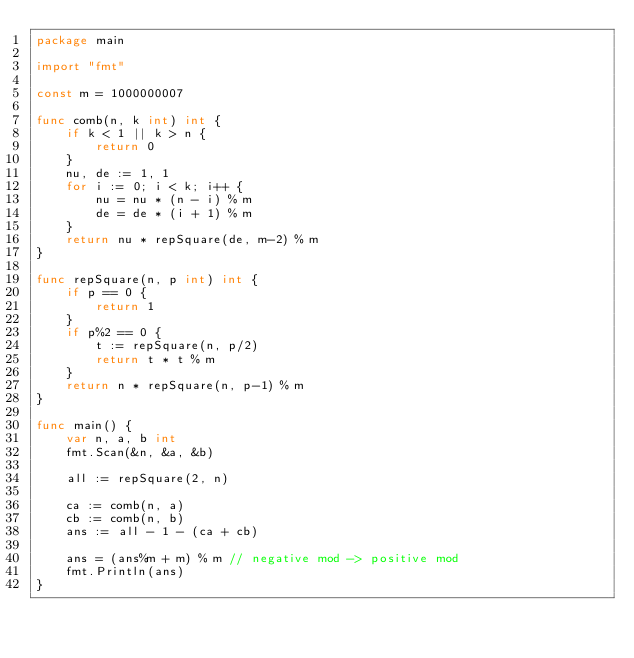<code> <loc_0><loc_0><loc_500><loc_500><_Go_>package main

import "fmt"

const m = 1000000007

func comb(n, k int) int {
	if k < 1 || k > n {
		return 0
	}
	nu, de := 1, 1
	for i := 0; i < k; i++ {
		nu = nu * (n - i) % m
		de = de * (i + 1) % m
	}
	return nu * repSquare(de, m-2) % m
}

func repSquare(n, p int) int {
	if p == 0 {
		return 1
	}
	if p%2 == 0 {
		t := repSquare(n, p/2)
		return t * t % m
	}
	return n * repSquare(n, p-1) % m
}

func main() {
	var n, a, b int
	fmt.Scan(&n, &a, &b)

	all := repSquare(2, n)

	ca := comb(n, a)
	cb := comb(n, b)
	ans := all - 1 - (ca + cb)

	ans = (ans%m + m) % m // negative mod -> positive mod
	fmt.Println(ans)
}
</code> 